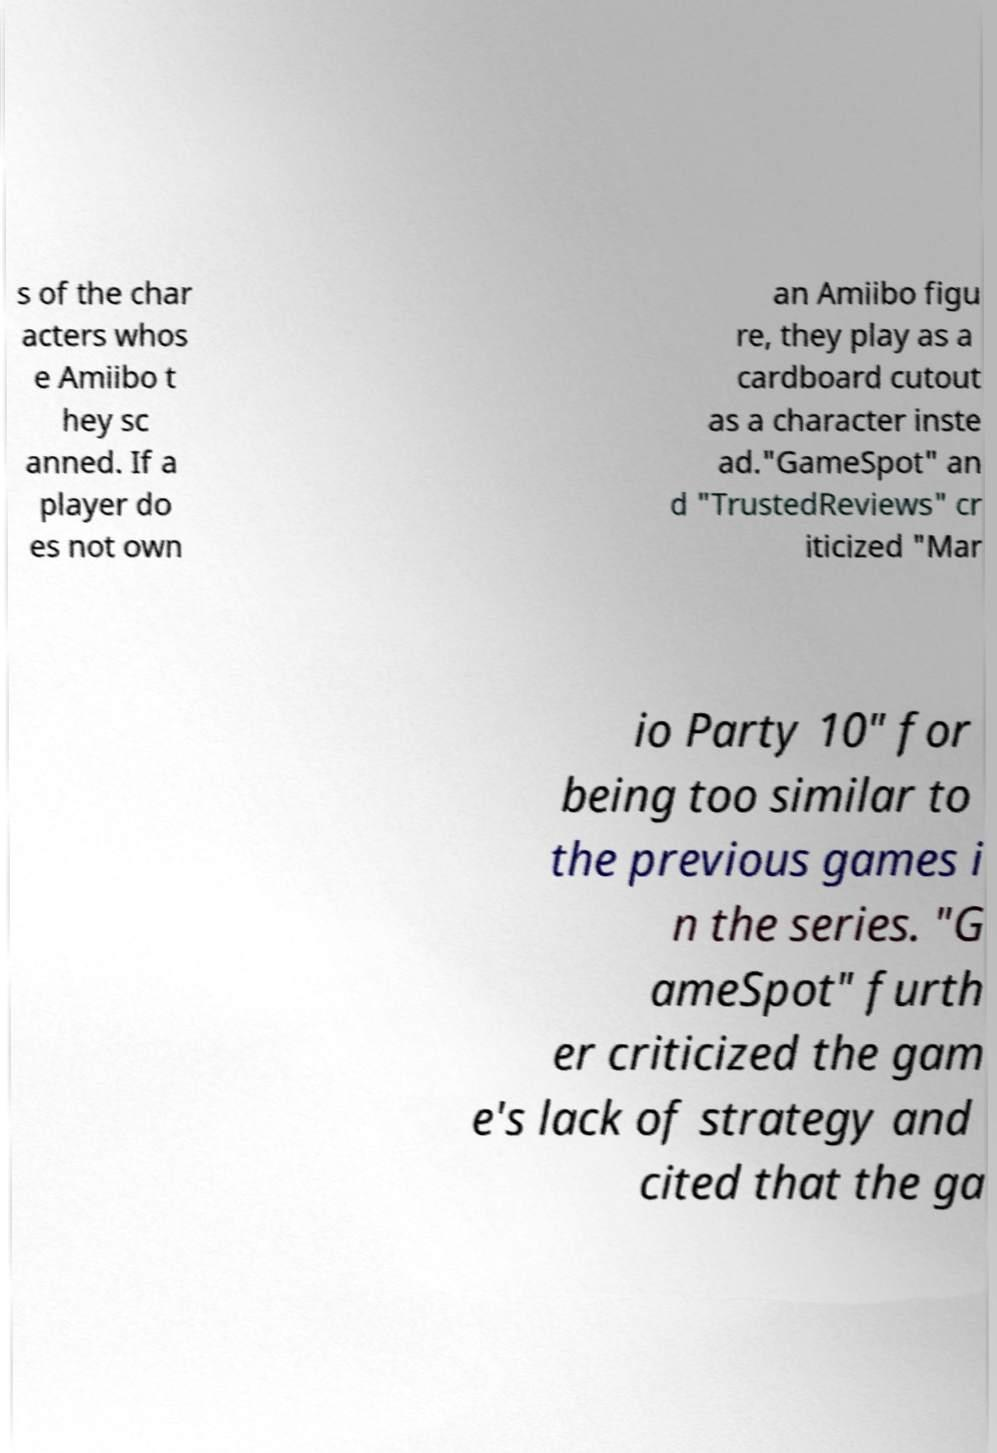Please read and relay the text visible in this image. What does it say? s of the char acters whos e Amiibo t hey sc anned. If a player do es not own an Amiibo figu re, they play as a cardboard cutout as a character inste ad."GameSpot" an d "TrustedReviews" cr iticized "Mar io Party 10" for being too similar to the previous games i n the series. "G ameSpot" furth er criticized the gam e's lack of strategy and cited that the ga 